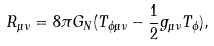Convert formula to latex. <formula><loc_0><loc_0><loc_500><loc_500>R _ { \mu \nu } = 8 \pi G _ { N } ( T _ { \phi \mu \nu } - \frac { 1 } { 2 } g _ { \mu \nu } T _ { \phi } ) ,</formula> 